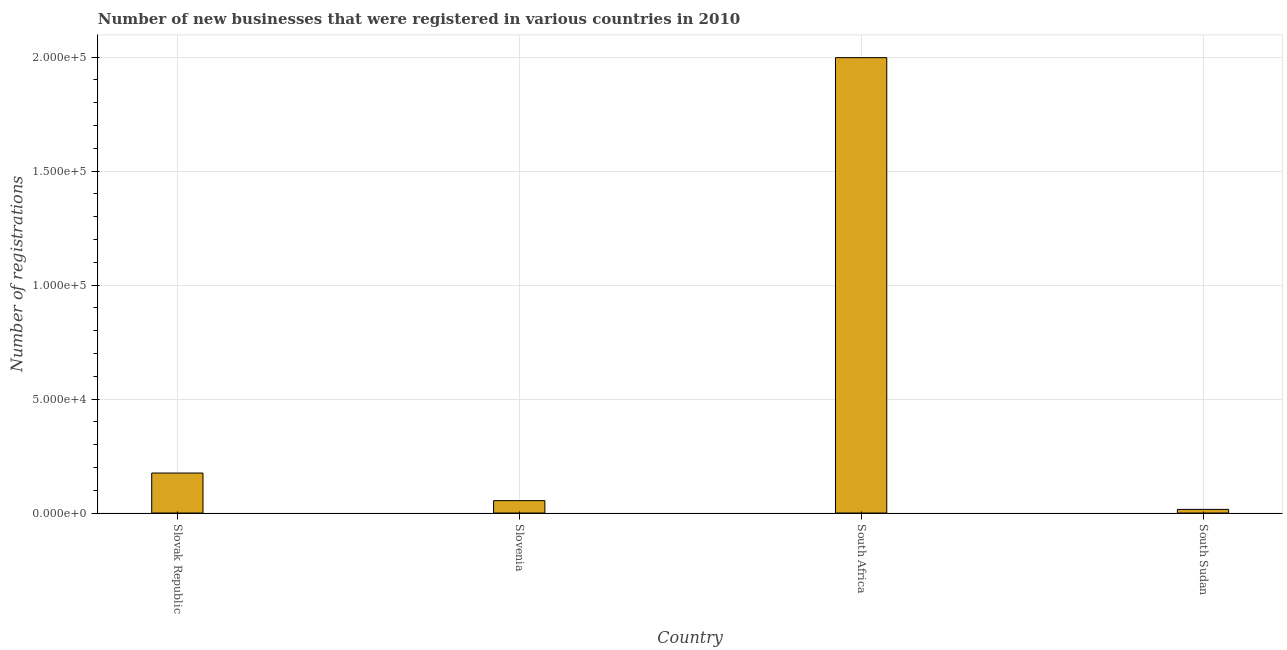Does the graph contain any zero values?
Your answer should be compact. No. Does the graph contain grids?
Offer a terse response. Yes. What is the title of the graph?
Keep it short and to the point. Number of new businesses that were registered in various countries in 2010. What is the label or title of the X-axis?
Offer a terse response. Country. What is the label or title of the Y-axis?
Give a very brief answer. Number of registrations. What is the number of new business registrations in Slovak Republic?
Offer a very short reply. 1.75e+04. Across all countries, what is the maximum number of new business registrations?
Give a very brief answer. 2.00e+05. Across all countries, what is the minimum number of new business registrations?
Keep it short and to the point. 1594. In which country was the number of new business registrations maximum?
Your answer should be very brief. South Africa. In which country was the number of new business registrations minimum?
Make the answer very short. South Sudan. What is the sum of the number of new business registrations?
Give a very brief answer. 2.24e+05. What is the difference between the number of new business registrations in Slovak Republic and Slovenia?
Your answer should be very brief. 1.21e+04. What is the average number of new business registrations per country?
Your response must be concise. 5.61e+04. What is the median number of new business registrations?
Your response must be concise. 1.15e+04. In how many countries, is the number of new business registrations greater than 60000 ?
Your answer should be very brief. 1. What is the ratio of the number of new business registrations in Slovak Republic to that in South Africa?
Provide a short and direct response. 0.09. Is the number of new business registrations in Slovak Republic less than that in South Africa?
Make the answer very short. Yes. What is the difference between the highest and the second highest number of new business registrations?
Make the answer very short. 1.82e+05. What is the difference between the highest and the lowest number of new business registrations?
Offer a terse response. 1.98e+05. In how many countries, is the number of new business registrations greater than the average number of new business registrations taken over all countries?
Ensure brevity in your answer.  1. Are all the bars in the graph horizontal?
Offer a terse response. No. How many countries are there in the graph?
Your answer should be compact. 4. What is the Number of registrations of Slovak Republic?
Provide a succinct answer. 1.75e+04. What is the Number of registrations of Slovenia?
Your response must be concise. 5438. What is the Number of registrations of South Africa?
Your response must be concise. 2.00e+05. What is the Number of registrations of South Sudan?
Offer a very short reply. 1594. What is the difference between the Number of registrations in Slovak Republic and Slovenia?
Make the answer very short. 1.21e+04. What is the difference between the Number of registrations in Slovak Republic and South Africa?
Give a very brief answer. -1.82e+05. What is the difference between the Number of registrations in Slovak Republic and South Sudan?
Ensure brevity in your answer.  1.60e+04. What is the difference between the Number of registrations in Slovenia and South Africa?
Provide a short and direct response. -1.94e+05. What is the difference between the Number of registrations in Slovenia and South Sudan?
Keep it short and to the point. 3844. What is the difference between the Number of registrations in South Africa and South Sudan?
Your answer should be compact. 1.98e+05. What is the ratio of the Number of registrations in Slovak Republic to that in Slovenia?
Your answer should be very brief. 3.23. What is the ratio of the Number of registrations in Slovak Republic to that in South Africa?
Keep it short and to the point. 0.09. What is the ratio of the Number of registrations in Slovak Republic to that in South Sudan?
Keep it short and to the point. 11.01. What is the ratio of the Number of registrations in Slovenia to that in South Africa?
Offer a terse response. 0.03. What is the ratio of the Number of registrations in Slovenia to that in South Sudan?
Offer a terse response. 3.41. What is the ratio of the Number of registrations in South Africa to that in South Sudan?
Your answer should be very brief. 125.32. 